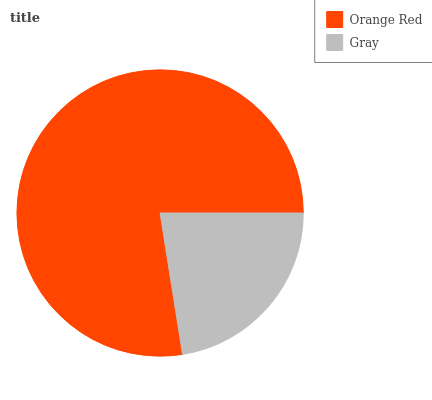Is Gray the minimum?
Answer yes or no. Yes. Is Orange Red the maximum?
Answer yes or no. Yes. Is Gray the maximum?
Answer yes or no. No. Is Orange Red greater than Gray?
Answer yes or no. Yes. Is Gray less than Orange Red?
Answer yes or no. Yes. Is Gray greater than Orange Red?
Answer yes or no. No. Is Orange Red less than Gray?
Answer yes or no. No. Is Orange Red the high median?
Answer yes or no. Yes. Is Gray the low median?
Answer yes or no. Yes. Is Gray the high median?
Answer yes or no. No. Is Orange Red the low median?
Answer yes or no. No. 